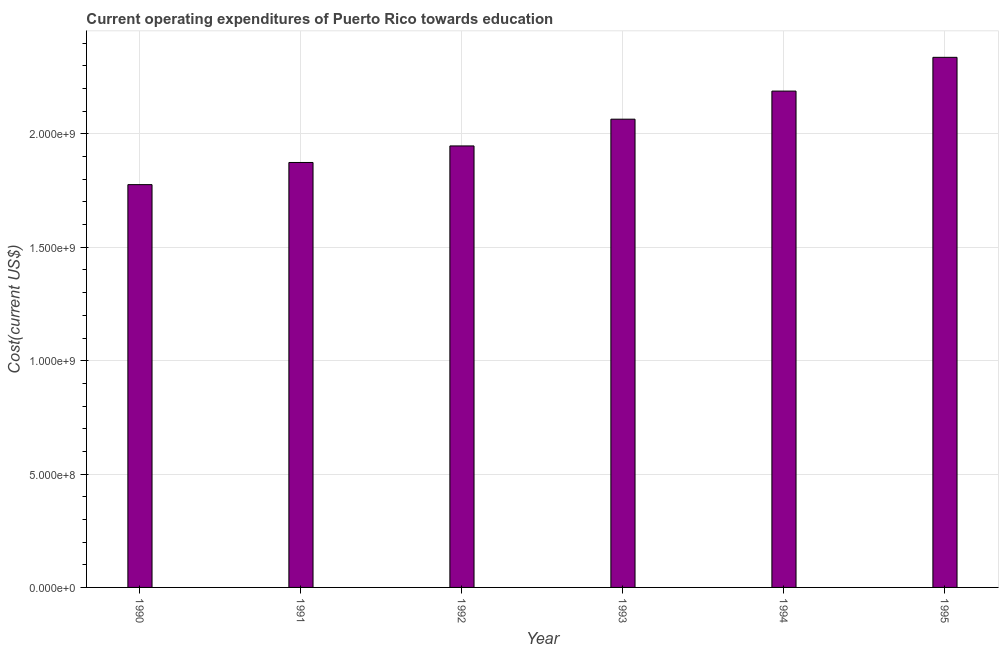What is the title of the graph?
Offer a very short reply. Current operating expenditures of Puerto Rico towards education. What is the label or title of the X-axis?
Keep it short and to the point. Year. What is the label or title of the Y-axis?
Provide a short and direct response. Cost(current US$). What is the education expenditure in 1993?
Keep it short and to the point. 2.07e+09. Across all years, what is the maximum education expenditure?
Offer a terse response. 2.34e+09. Across all years, what is the minimum education expenditure?
Your answer should be very brief. 1.78e+09. In which year was the education expenditure maximum?
Your answer should be very brief. 1995. What is the sum of the education expenditure?
Ensure brevity in your answer.  1.22e+1. What is the difference between the education expenditure in 1994 and 1995?
Your answer should be compact. -1.49e+08. What is the average education expenditure per year?
Offer a very short reply. 2.03e+09. What is the median education expenditure?
Offer a very short reply. 2.01e+09. What is the ratio of the education expenditure in 1991 to that in 1993?
Your answer should be very brief. 0.91. Is the education expenditure in 1991 less than that in 1995?
Keep it short and to the point. Yes. What is the difference between the highest and the second highest education expenditure?
Make the answer very short. 1.49e+08. Is the sum of the education expenditure in 1991 and 1995 greater than the maximum education expenditure across all years?
Keep it short and to the point. Yes. What is the difference between the highest and the lowest education expenditure?
Give a very brief answer. 5.61e+08. In how many years, is the education expenditure greater than the average education expenditure taken over all years?
Your answer should be compact. 3. Are all the bars in the graph horizontal?
Provide a succinct answer. No. How many years are there in the graph?
Ensure brevity in your answer.  6. What is the difference between two consecutive major ticks on the Y-axis?
Give a very brief answer. 5.00e+08. Are the values on the major ticks of Y-axis written in scientific E-notation?
Make the answer very short. Yes. What is the Cost(current US$) in 1990?
Keep it short and to the point. 1.78e+09. What is the Cost(current US$) of 1991?
Your answer should be compact. 1.87e+09. What is the Cost(current US$) of 1992?
Provide a succinct answer. 1.95e+09. What is the Cost(current US$) in 1993?
Offer a very short reply. 2.07e+09. What is the Cost(current US$) of 1994?
Give a very brief answer. 2.19e+09. What is the Cost(current US$) in 1995?
Provide a succinct answer. 2.34e+09. What is the difference between the Cost(current US$) in 1990 and 1991?
Keep it short and to the point. -9.78e+07. What is the difference between the Cost(current US$) in 1990 and 1992?
Provide a short and direct response. -1.71e+08. What is the difference between the Cost(current US$) in 1990 and 1993?
Give a very brief answer. -2.89e+08. What is the difference between the Cost(current US$) in 1990 and 1994?
Make the answer very short. -4.13e+08. What is the difference between the Cost(current US$) in 1990 and 1995?
Ensure brevity in your answer.  -5.61e+08. What is the difference between the Cost(current US$) in 1991 and 1992?
Ensure brevity in your answer.  -7.29e+07. What is the difference between the Cost(current US$) in 1991 and 1993?
Offer a terse response. -1.91e+08. What is the difference between the Cost(current US$) in 1991 and 1994?
Give a very brief answer. -3.15e+08. What is the difference between the Cost(current US$) in 1991 and 1995?
Make the answer very short. -4.64e+08. What is the difference between the Cost(current US$) in 1992 and 1993?
Offer a terse response. -1.18e+08. What is the difference between the Cost(current US$) in 1992 and 1994?
Provide a short and direct response. -2.42e+08. What is the difference between the Cost(current US$) in 1992 and 1995?
Your answer should be very brief. -3.91e+08. What is the difference between the Cost(current US$) in 1993 and 1994?
Your answer should be very brief. -1.24e+08. What is the difference between the Cost(current US$) in 1993 and 1995?
Your response must be concise. -2.73e+08. What is the difference between the Cost(current US$) in 1994 and 1995?
Offer a terse response. -1.49e+08. What is the ratio of the Cost(current US$) in 1990 to that in 1991?
Make the answer very short. 0.95. What is the ratio of the Cost(current US$) in 1990 to that in 1992?
Offer a terse response. 0.91. What is the ratio of the Cost(current US$) in 1990 to that in 1993?
Offer a terse response. 0.86. What is the ratio of the Cost(current US$) in 1990 to that in 1994?
Offer a terse response. 0.81. What is the ratio of the Cost(current US$) in 1990 to that in 1995?
Keep it short and to the point. 0.76. What is the ratio of the Cost(current US$) in 1991 to that in 1993?
Your answer should be compact. 0.91. What is the ratio of the Cost(current US$) in 1991 to that in 1994?
Provide a short and direct response. 0.86. What is the ratio of the Cost(current US$) in 1991 to that in 1995?
Ensure brevity in your answer.  0.8. What is the ratio of the Cost(current US$) in 1992 to that in 1993?
Provide a short and direct response. 0.94. What is the ratio of the Cost(current US$) in 1992 to that in 1994?
Your answer should be very brief. 0.89. What is the ratio of the Cost(current US$) in 1992 to that in 1995?
Provide a succinct answer. 0.83. What is the ratio of the Cost(current US$) in 1993 to that in 1994?
Your answer should be very brief. 0.94. What is the ratio of the Cost(current US$) in 1993 to that in 1995?
Your response must be concise. 0.88. What is the ratio of the Cost(current US$) in 1994 to that in 1995?
Keep it short and to the point. 0.94. 